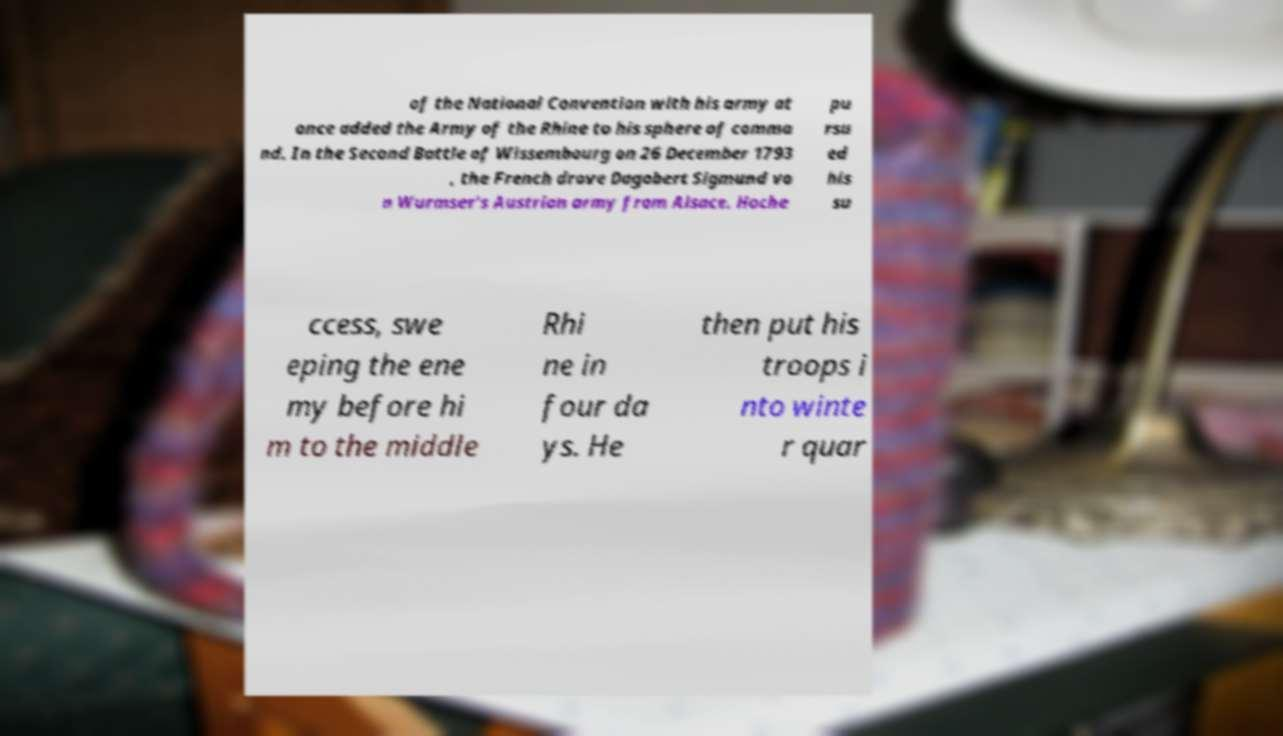Could you assist in decoding the text presented in this image and type it out clearly? of the National Convention with his army at once added the Army of the Rhine to his sphere of comma nd. In the Second Battle of Wissembourg on 26 December 1793 , the French drove Dagobert Sigmund vo n Wurmser's Austrian army from Alsace. Hoche pu rsu ed his su ccess, swe eping the ene my before hi m to the middle Rhi ne in four da ys. He then put his troops i nto winte r quar 